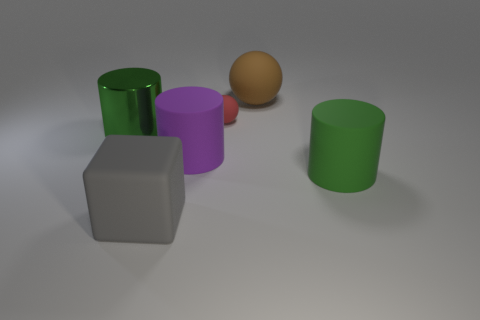What number of big things are brown matte things or gray balls?
Your answer should be very brief. 1. There is a cylinder that is on the left side of the big gray block; are there any metal cylinders that are to the right of it?
Offer a terse response. No. Is there a large gray cube?
Keep it short and to the point. Yes. There is a large cylinder on the right side of the brown matte sphere that is right of the large purple rubber cylinder; what color is it?
Make the answer very short. Green. What is the material of the big purple thing that is the same shape as the big green metallic thing?
Your answer should be very brief. Rubber. How many brown shiny cylinders are the same size as the purple cylinder?
Make the answer very short. 0. What size is the green thing that is made of the same material as the large block?
Offer a very short reply. Large. How many other big purple things have the same shape as the large purple matte thing?
Make the answer very short. 0. What number of small red matte balls are there?
Offer a terse response. 1. There is a large matte object behind the big green metal cylinder; is it the same shape as the large gray rubber object?
Provide a short and direct response. No. 